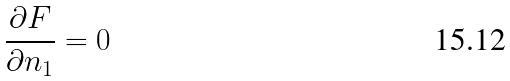<formula> <loc_0><loc_0><loc_500><loc_500>\frac { \partial F } { \partial n _ { 1 } } = 0</formula> 